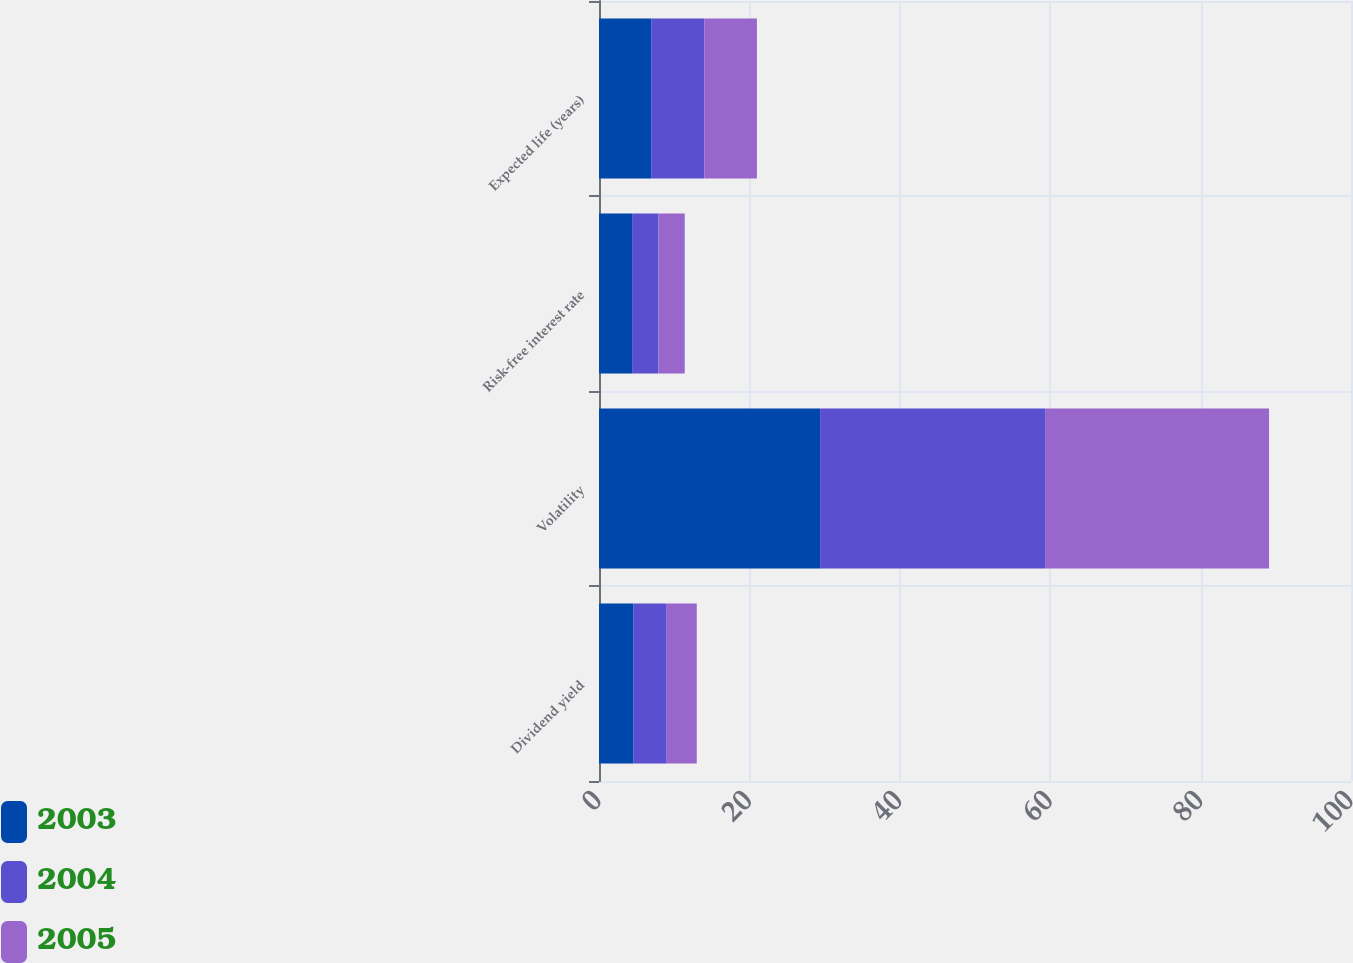Convert chart. <chart><loc_0><loc_0><loc_500><loc_500><stacked_bar_chart><ecel><fcel>Dividend yield<fcel>Volatility<fcel>Risk-free interest rate<fcel>Expected life (years)<nl><fcel>2003<fcel>4.6<fcel>29.4<fcel>4.4<fcel>7<nl><fcel>2004<fcel>4.4<fcel>30<fcel>3.5<fcel>7<nl><fcel>2005<fcel>4<fcel>29.7<fcel>3.5<fcel>7<nl></chart> 